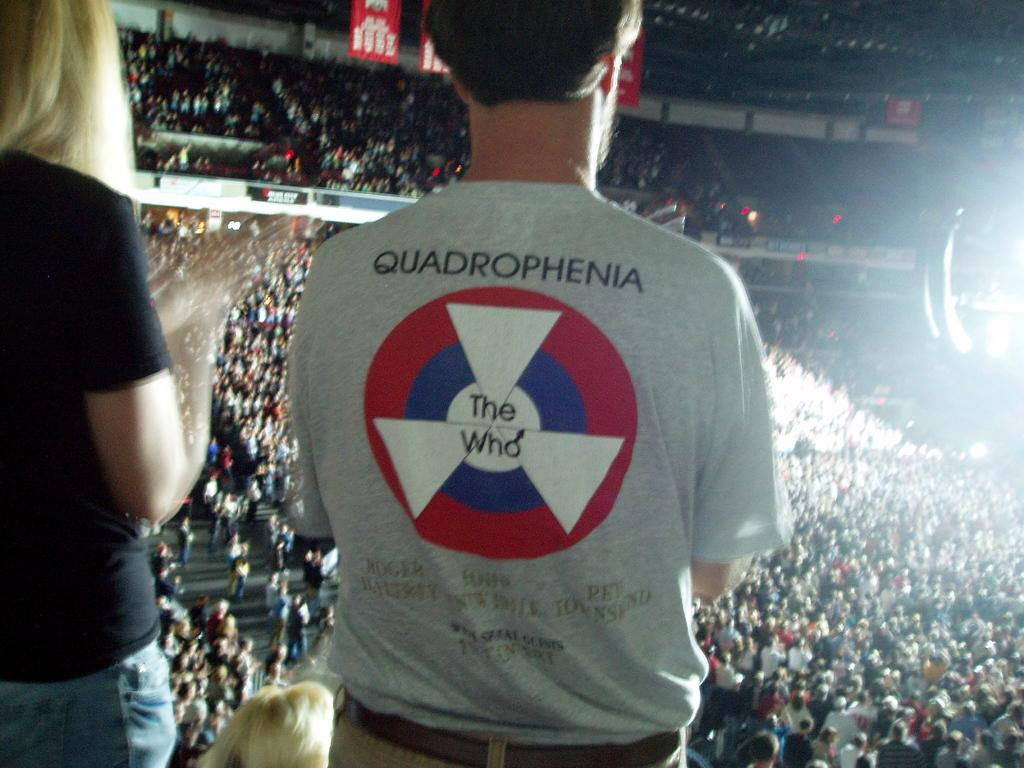<image>
Offer a succinct explanation of the picture presented. a person in a THE WHO concert shirt looking out over a crowded arena 